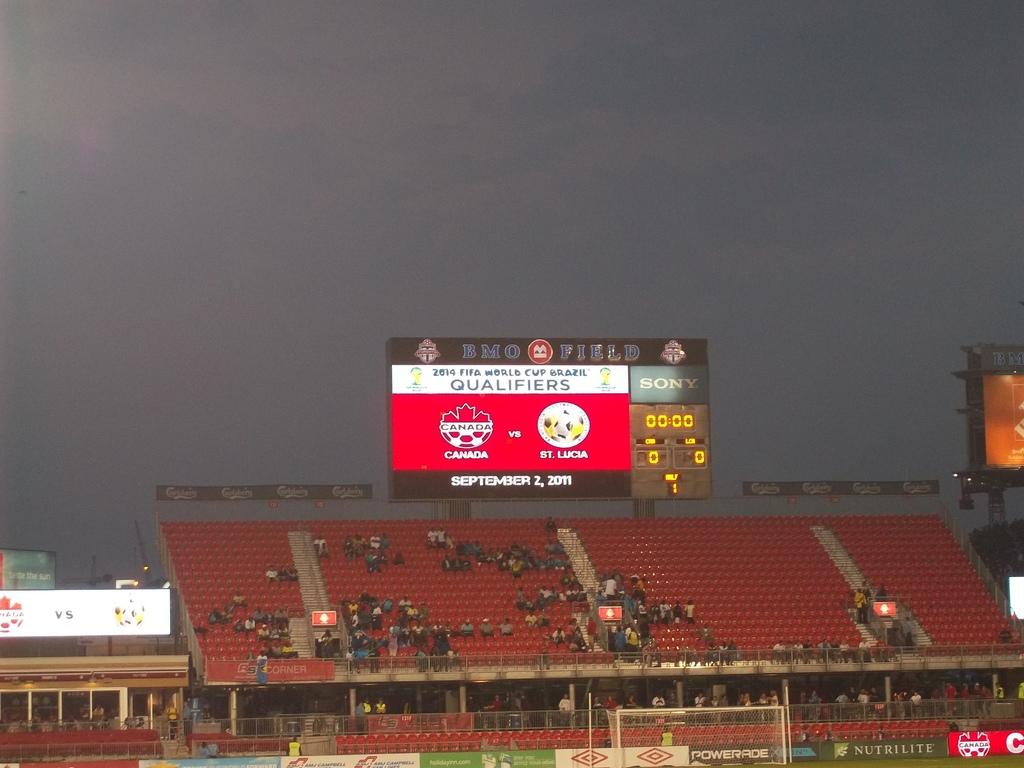Provide a one-sentence caption for the provided image. The scoreboard of a soccer match between Canada and St. Lucia shows a score of 0-0. 